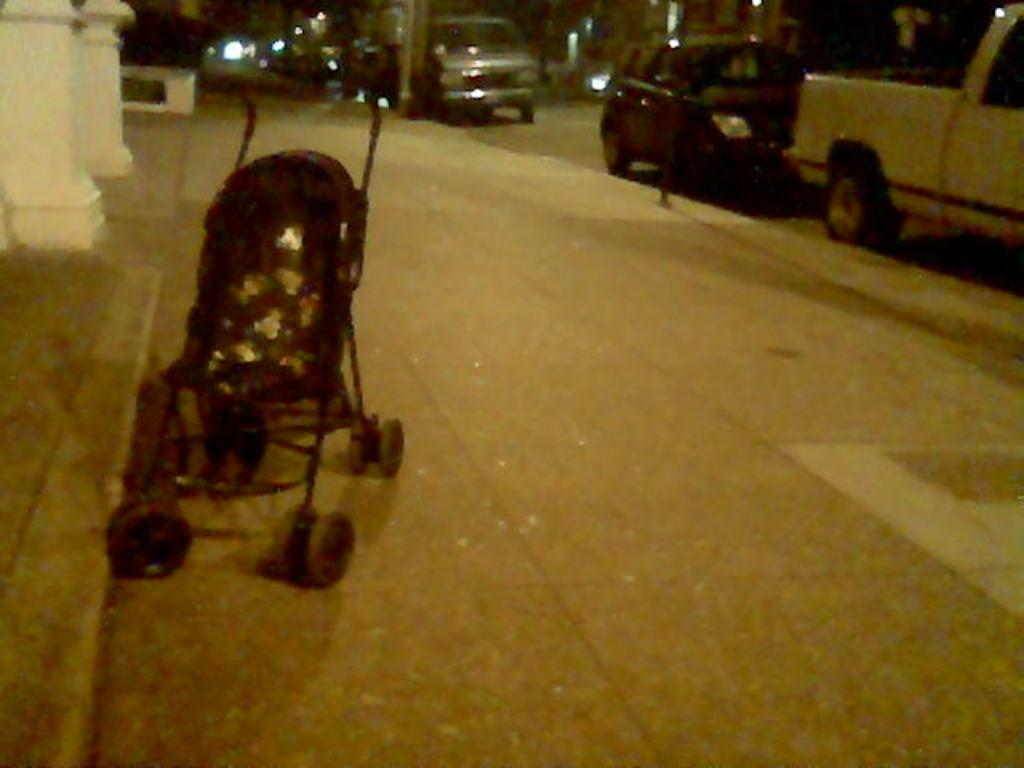What can be seen on the footpath in the image? There is a baby stroller on the footpath. What is located behind the baby stroller? There are two pillars behind the baby stroller. What is visible on the right side of the image? There are vehicles on the road on the right side of the image. What type of pain is the baby experiencing in the image? There is no indication of pain or any baby in the image; it only shows a baby stroller and two pillars. 